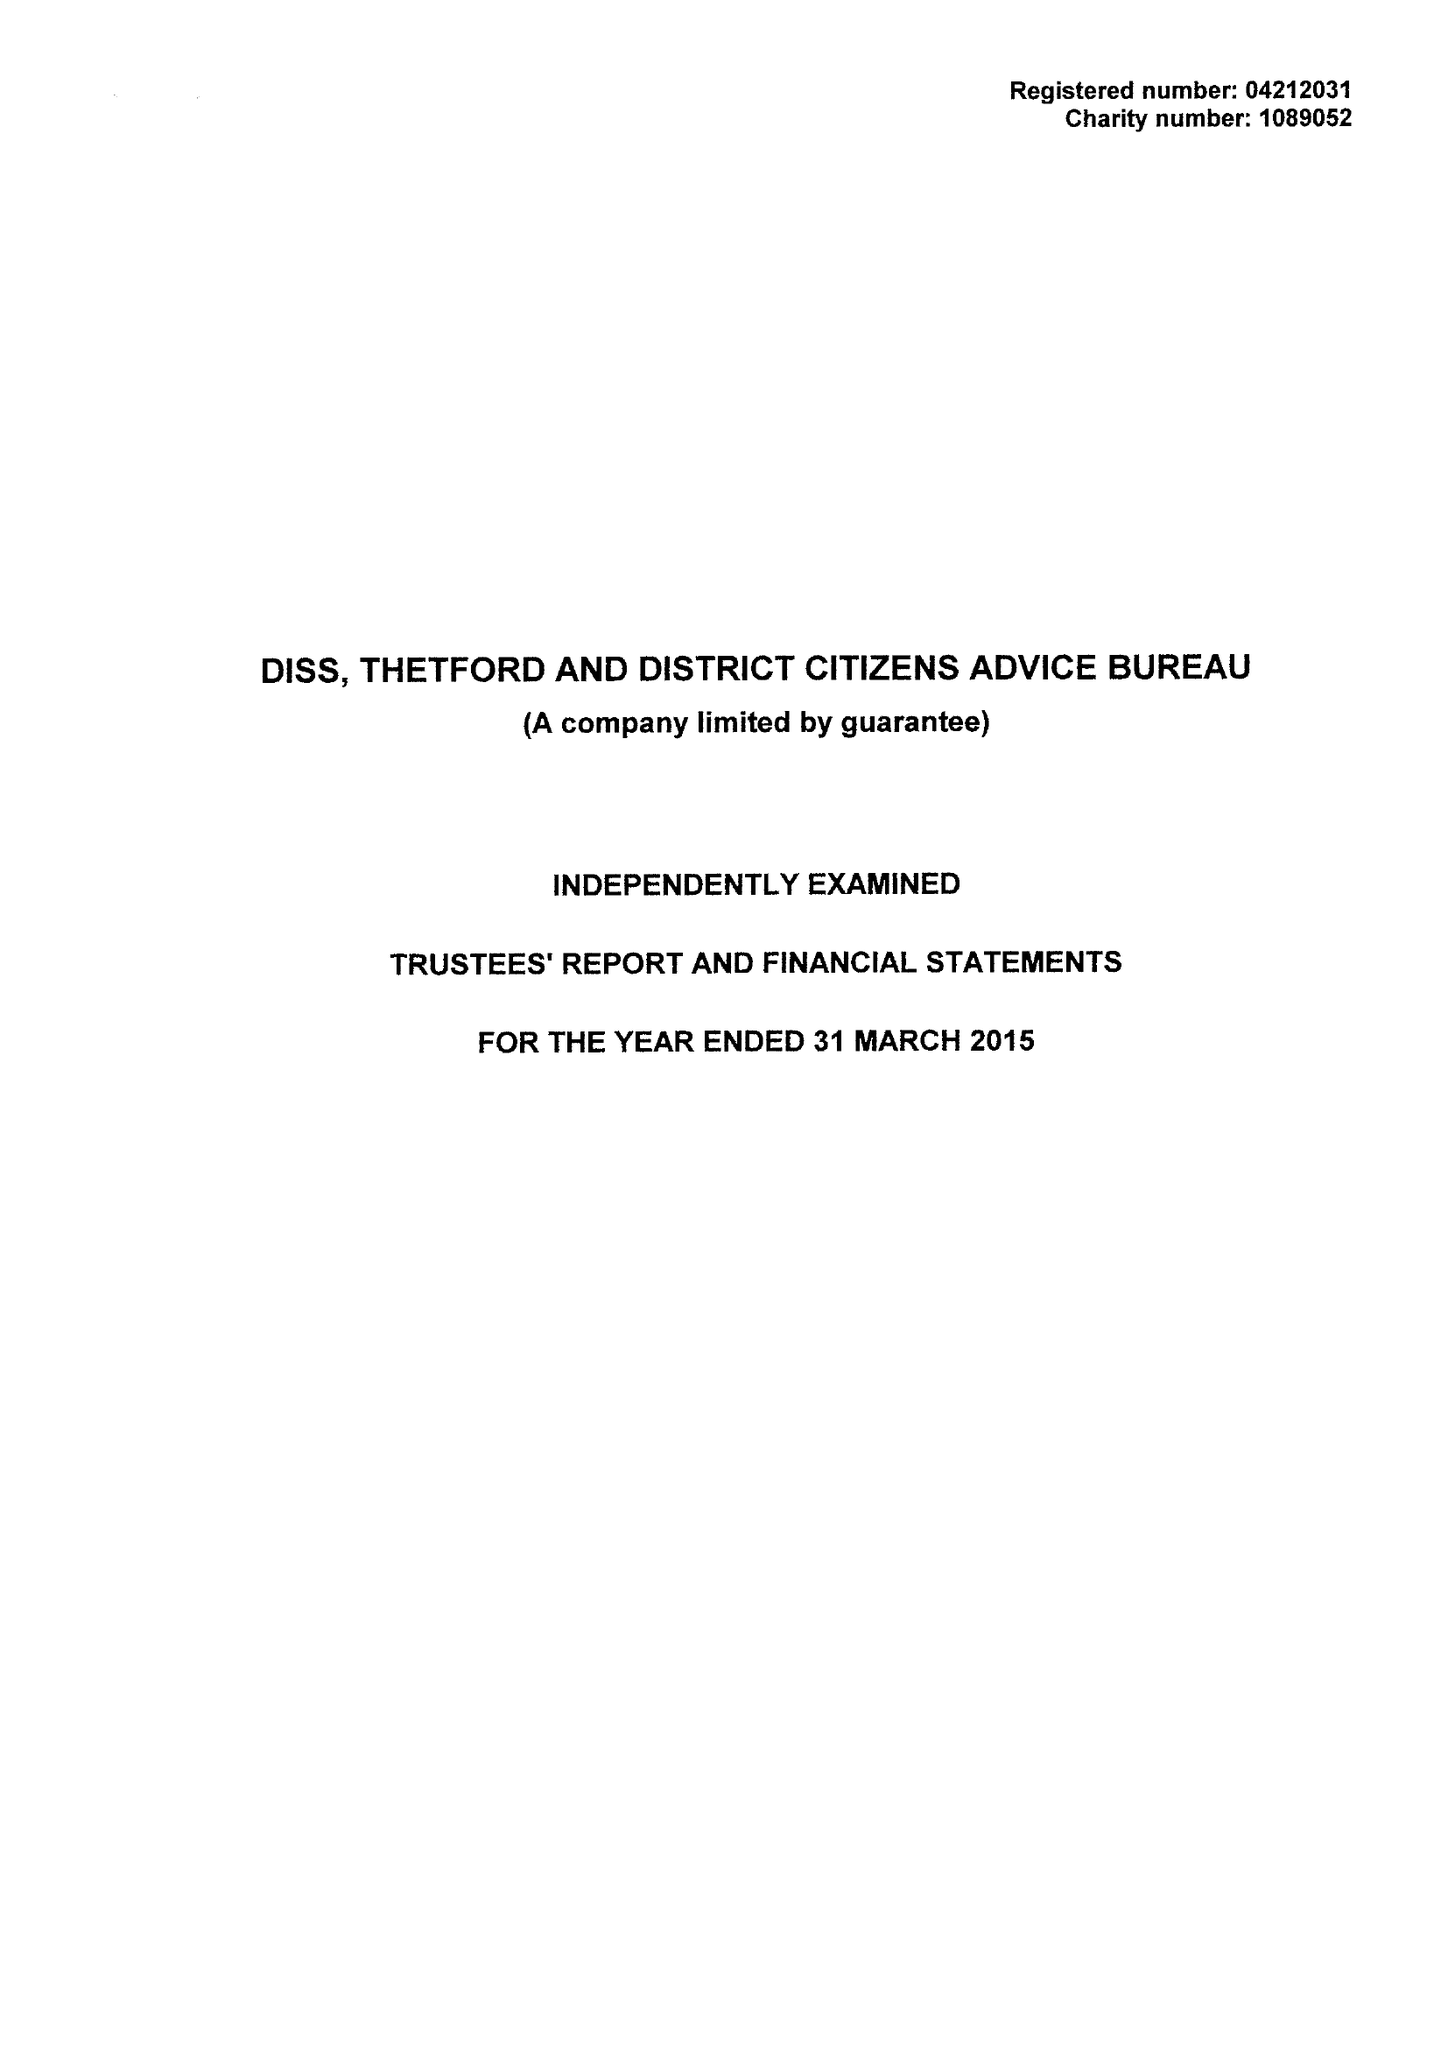What is the value for the spending_annually_in_british_pounds?
Answer the question using a single word or phrase. 361969.00 